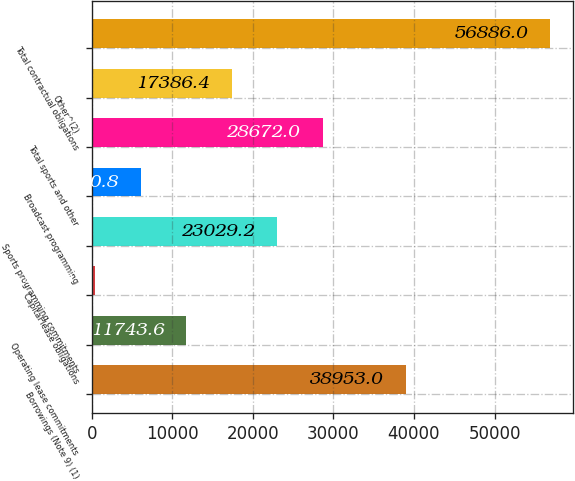<chart> <loc_0><loc_0><loc_500><loc_500><bar_chart><fcel>Borrowings (Note 9) (1)<fcel>Operating lease commitments<fcel>Capital lease obligations<fcel>Sports programming commitments<fcel>Broadcast programming<fcel>Total sports and other<fcel>Other^(2)<fcel>Total contractual obligations<nl><fcel>38953<fcel>11743.6<fcel>458<fcel>23029.2<fcel>6100.8<fcel>28672<fcel>17386.4<fcel>56886<nl></chart> 